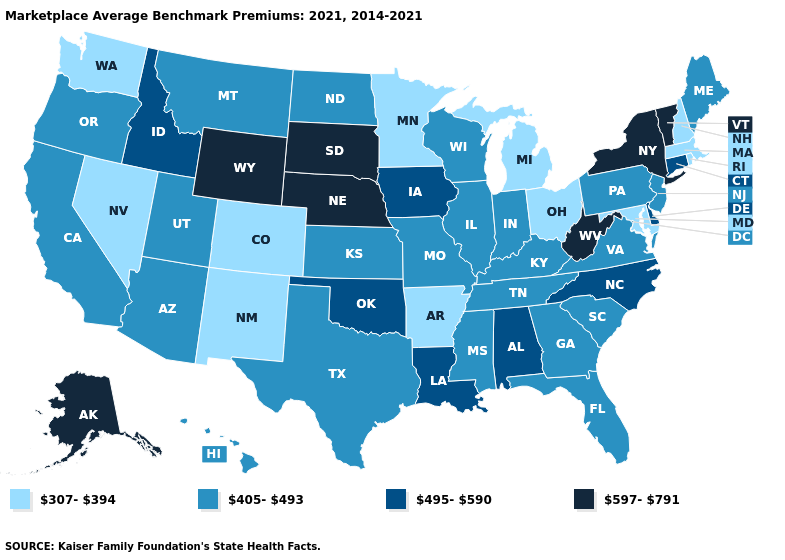What is the value of Minnesota?
Concise answer only. 307-394. Among the states that border Rhode Island , does Massachusetts have the lowest value?
Give a very brief answer. Yes. Which states have the lowest value in the USA?
Write a very short answer. Arkansas, Colorado, Maryland, Massachusetts, Michigan, Minnesota, Nevada, New Hampshire, New Mexico, Ohio, Rhode Island, Washington. What is the value of Wisconsin?
Give a very brief answer. 405-493. Does the first symbol in the legend represent the smallest category?
Be succinct. Yes. Does the map have missing data?
Be succinct. No. Does New Hampshire have the lowest value in the Northeast?
Answer briefly. Yes. What is the value of Colorado?
Write a very short answer. 307-394. What is the value of Connecticut?
Concise answer only. 495-590. Name the states that have a value in the range 405-493?
Answer briefly. Arizona, California, Florida, Georgia, Hawaii, Illinois, Indiana, Kansas, Kentucky, Maine, Mississippi, Missouri, Montana, New Jersey, North Dakota, Oregon, Pennsylvania, South Carolina, Tennessee, Texas, Utah, Virginia, Wisconsin. Does Arkansas have a lower value than North Carolina?
Keep it brief. Yes. What is the value of Maine?
Give a very brief answer. 405-493. What is the lowest value in the USA?
Concise answer only. 307-394. Which states have the lowest value in the USA?
Give a very brief answer. Arkansas, Colorado, Maryland, Massachusetts, Michigan, Minnesota, Nevada, New Hampshire, New Mexico, Ohio, Rhode Island, Washington. What is the highest value in the USA?
Concise answer only. 597-791. 